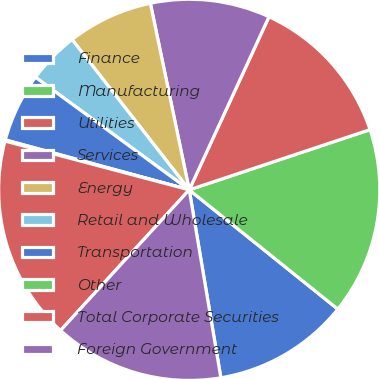<chart> <loc_0><loc_0><loc_500><loc_500><pie_chart><fcel>Finance<fcel>Manufacturing<fcel>Utilities<fcel>Services<fcel>Energy<fcel>Retail and Wholesale<fcel>Transportation<fcel>Other<fcel>Total Corporate Securities<fcel>Foreign Government<nl><fcel>11.58%<fcel>15.88%<fcel>13.01%<fcel>10.14%<fcel>7.27%<fcel>4.4%<fcel>5.84%<fcel>0.1%<fcel>17.32%<fcel>14.45%<nl></chart> 